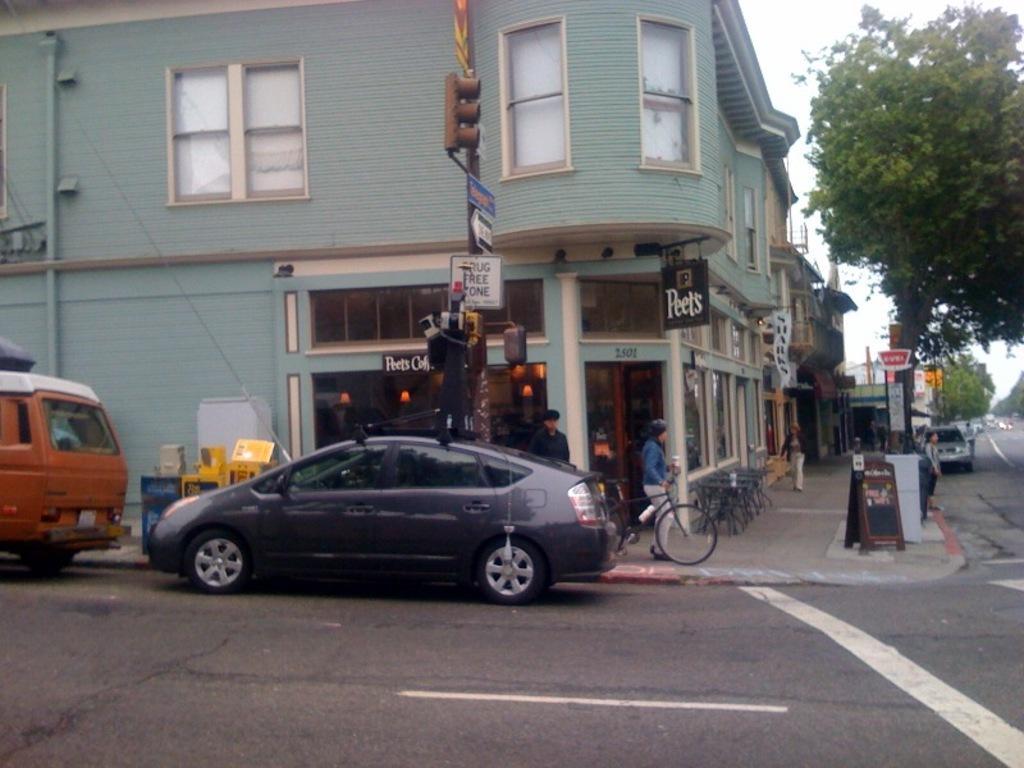In one or two sentences, can you explain what this image depicts? This picture shows buildings and we see trees and few cars parked and we see a human holding a bicycle and we see few people standing and few boards to the pole and a traffic signal light and we see chairs and tables on the sidewalk and a woman walking and we see a cloudy sky. 